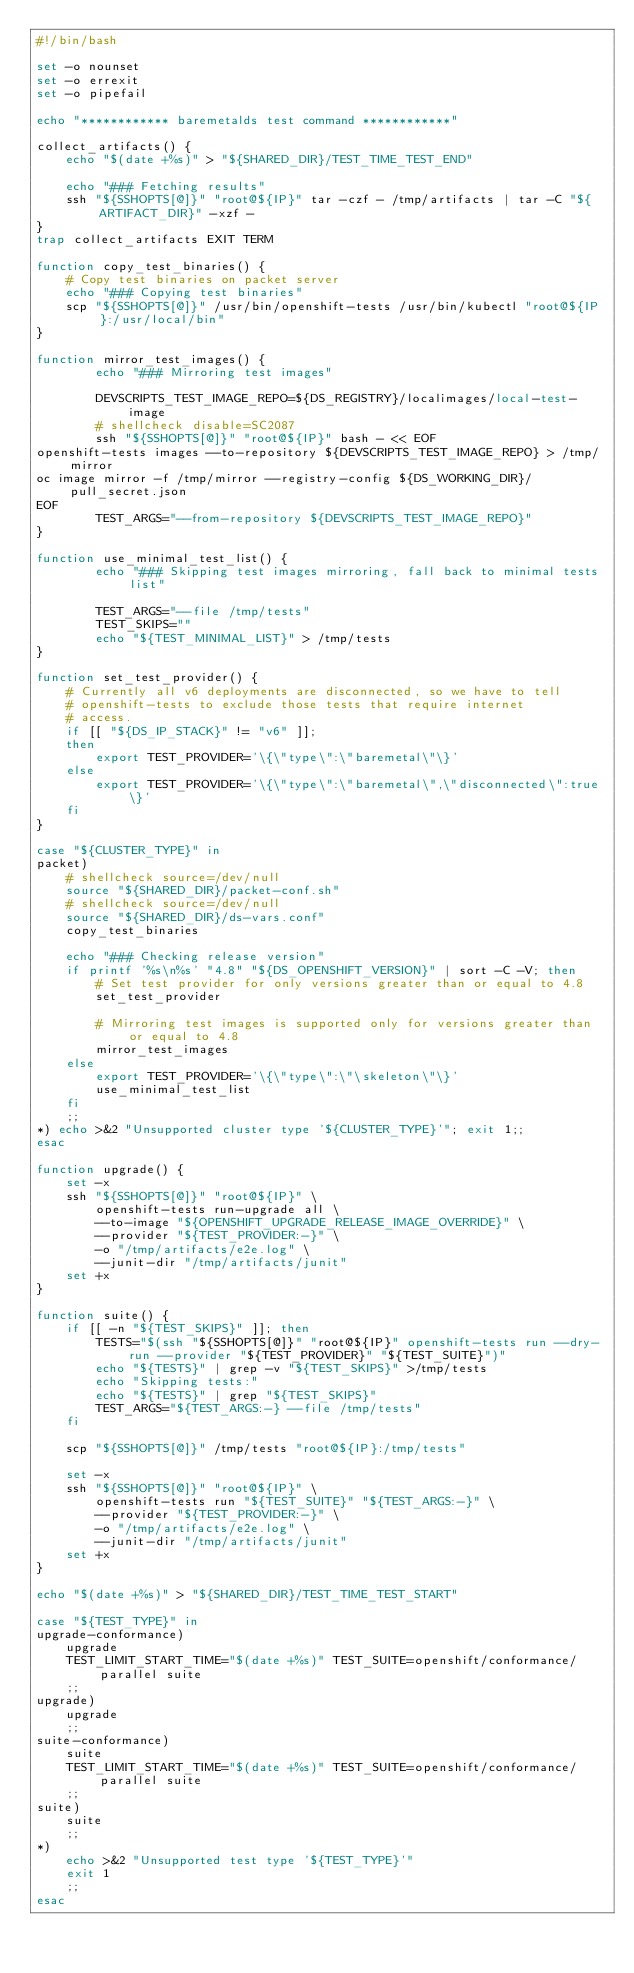<code> <loc_0><loc_0><loc_500><loc_500><_Bash_>#!/bin/bash

set -o nounset
set -o errexit
set -o pipefail

echo "************ baremetalds test command ************"

collect_artifacts() {
    echo "$(date +%s)" > "${SHARED_DIR}/TEST_TIME_TEST_END"

    echo "### Fetching results"
    ssh "${SSHOPTS[@]}" "root@${IP}" tar -czf - /tmp/artifacts | tar -C "${ARTIFACT_DIR}" -xzf -
}
trap collect_artifacts EXIT TERM

function copy_test_binaries() {
    # Copy test binaries on packet server
    echo "### Copying test binaries"
    scp "${SSHOPTS[@]}" /usr/bin/openshift-tests /usr/bin/kubectl "root@${IP}:/usr/local/bin"
}

function mirror_test_images() {
        echo "### Mirroring test images"

        DEVSCRIPTS_TEST_IMAGE_REPO=${DS_REGISTRY}/localimages/local-test-image
        # shellcheck disable=SC2087
        ssh "${SSHOPTS[@]}" "root@${IP}" bash - << EOF
openshift-tests images --to-repository ${DEVSCRIPTS_TEST_IMAGE_REPO} > /tmp/mirror
oc image mirror -f /tmp/mirror --registry-config ${DS_WORKING_DIR}/pull_secret.json
EOF
        TEST_ARGS="--from-repository ${DEVSCRIPTS_TEST_IMAGE_REPO}"
}

function use_minimal_test_list() {
        echo "### Skipping test images mirroring, fall back to minimal tests list"

        TEST_ARGS="--file /tmp/tests"
        TEST_SKIPS=""
        echo "${TEST_MINIMAL_LIST}" > /tmp/tests
}

function set_test_provider() {
    # Currently all v6 deployments are disconnected, so we have to tell
    # openshift-tests to exclude those tests that require internet
    # access.
    if [[ "${DS_IP_STACK}" != "v6" ]];
    then
        export TEST_PROVIDER='\{\"type\":\"baremetal\"\}'
    else
        export TEST_PROVIDER='\{\"type\":\"baremetal\",\"disconnected\":true\}'
    fi
}

case "${CLUSTER_TYPE}" in
packet)
    # shellcheck source=/dev/null
    source "${SHARED_DIR}/packet-conf.sh"
    # shellcheck source=/dev/null
    source "${SHARED_DIR}/ds-vars.conf"
    copy_test_binaries

    echo "### Checking release version"
    if printf '%s\n%s' "4.8" "${DS_OPENSHIFT_VERSION}" | sort -C -V; then
        # Set test provider for only versions greater than or equal to 4.8
        set_test_provider

        # Mirroring test images is supported only for versions greater than or equal to 4.8
        mirror_test_images
    else
        export TEST_PROVIDER='\{\"type\":\"\skeleton\"\}'
        use_minimal_test_list
    fi
    ;;
*) echo >&2 "Unsupported cluster type '${CLUSTER_TYPE}'"; exit 1;;
esac

function upgrade() {
    set -x
    ssh "${SSHOPTS[@]}" "root@${IP}" \
        openshift-tests run-upgrade all \
        --to-image "${OPENSHIFT_UPGRADE_RELEASE_IMAGE_OVERRIDE}" \
        --provider "${TEST_PROVIDER:-}" \
        -o "/tmp/artifacts/e2e.log" \
        --junit-dir "/tmp/artifacts/junit"
    set +x
}

function suite() {
    if [[ -n "${TEST_SKIPS}" ]]; then
        TESTS="$(ssh "${SSHOPTS[@]}" "root@${IP}" openshift-tests run --dry-run --provider "${TEST_PROVIDER}" "${TEST_SUITE}")"
        echo "${TESTS}" | grep -v "${TEST_SKIPS}" >/tmp/tests
        echo "Skipping tests:"
        echo "${TESTS}" | grep "${TEST_SKIPS}"
        TEST_ARGS="${TEST_ARGS:-} --file /tmp/tests"
    fi

    scp "${SSHOPTS[@]}" /tmp/tests "root@${IP}:/tmp/tests"

    set -x
    ssh "${SSHOPTS[@]}" "root@${IP}" \
        openshift-tests run "${TEST_SUITE}" "${TEST_ARGS:-}" \
        --provider "${TEST_PROVIDER:-}" \
        -o "/tmp/artifacts/e2e.log" \
        --junit-dir "/tmp/artifacts/junit"
    set +x
}

echo "$(date +%s)" > "${SHARED_DIR}/TEST_TIME_TEST_START"

case "${TEST_TYPE}" in
upgrade-conformance)
    upgrade
    TEST_LIMIT_START_TIME="$(date +%s)" TEST_SUITE=openshift/conformance/parallel suite
    ;;
upgrade)
    upgrade
    ;;
suite-conformance)
    suite
    TEST_LIMIT_START_TIME="$(date +%s)" TEST_SUITE=openshift/conformance/parallel suite
    ;;
suite)
    suite
    ;;
*)
    echo >&2 "Unsupported test type '${TEST_TYPE}'"
    exit 1
    ;;
esac
</code> 